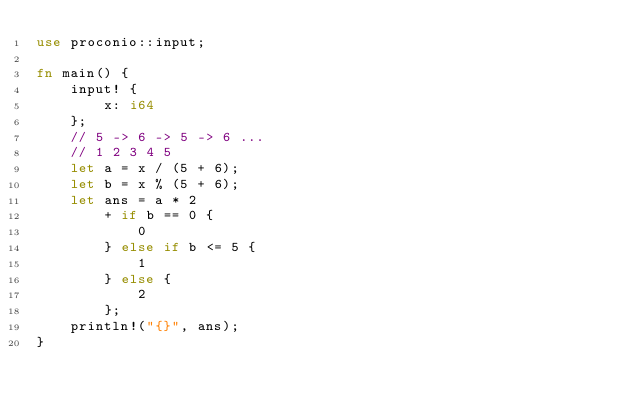Convert code to text. <code><loc_0><loc_0><loc_500><loc_500><_Rust_>use proconio::input;

fn main() {
    input! {
        x: i64
    };
    // 5 -> 6 -> 5 -> 6 ...
    // 1 2 3 4 5
    let a = x / (5 + 6);
    let b = x % (5 + 6);
    let ans = a * 2
        + if b == 0 {
            0
        } else if b <= 5 {
            1
        } else {
            2
        };
    println!("{}", ans);
}
</code> 